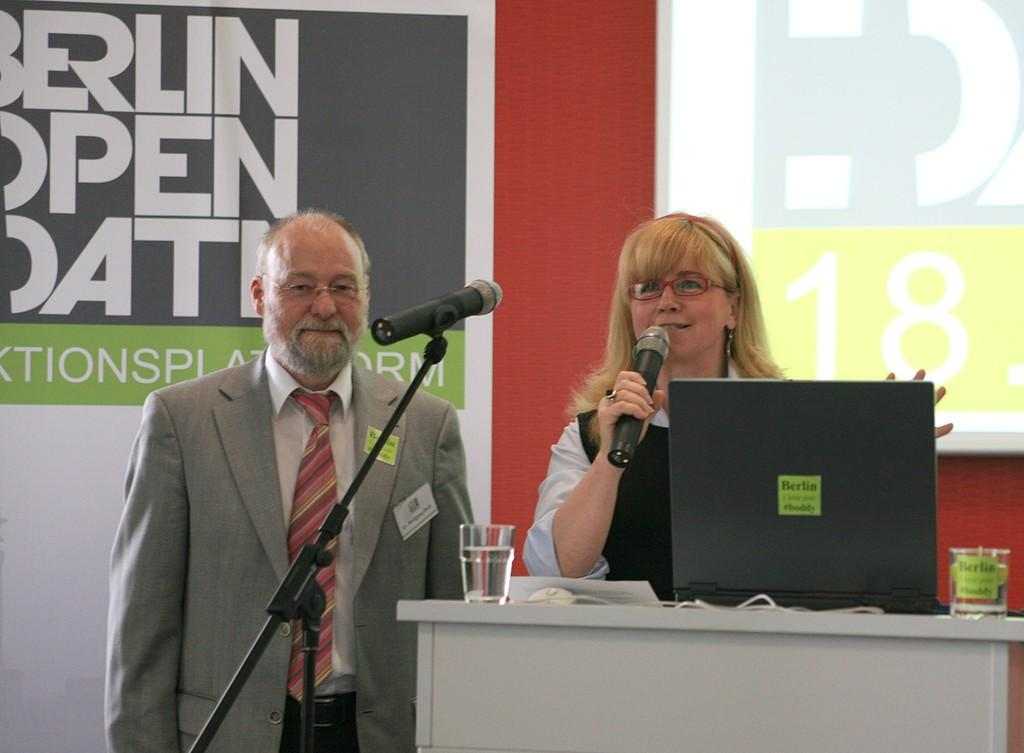How many people are present in the image? There is a man and a woman present in the image. What is the woman doing in the image? The woman is speaking with the help of a microphone. What object is on the table in the image? There is a monitor on a table in the image. What can be used for drinking in the image? There is a water glass in the image. What type of door can be seen in the image? There is no door present in the image. What color is the wall behind the man in the image? There is no wall visible in the image; it is not mentioned in the provided facts. 